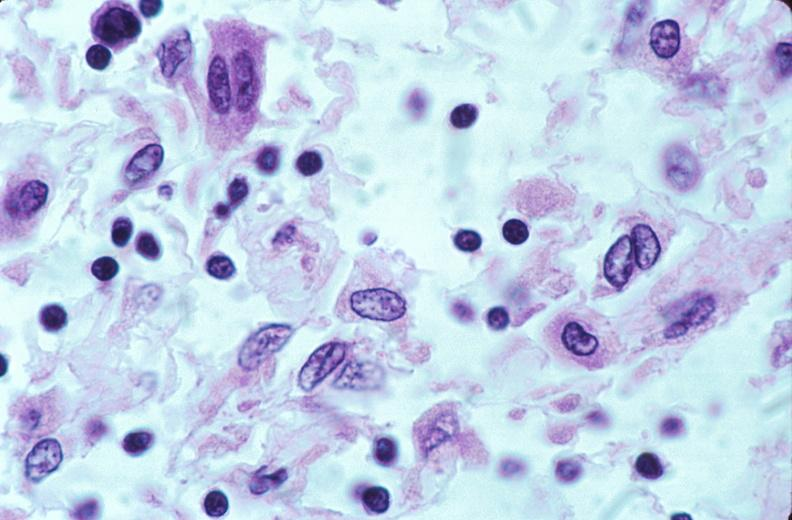does this image show lymph nodes, nodular sclerosing hodgkins disease?
Answer the question using a single word or phrase. Yes 